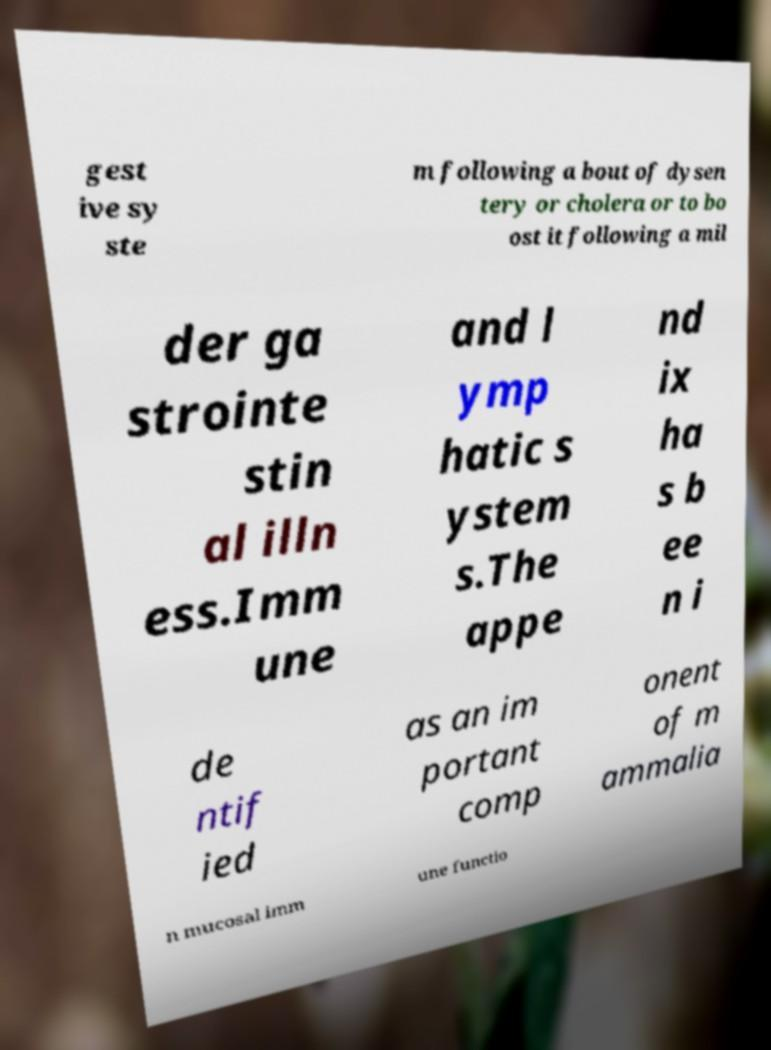Can you read and provide the text displayed in the image?This photo seems to have some interesting text. Can you extract and type it out for me? gest ive sy ste m following a bout of dysen tery or cholera or to bo ost it following a mil der ga strointe stin al illn ess.Imm une and l ymp hatic s ystem s.The appe nd ix ha s b ee n i de ntif ied as an im portant comp onent of m ammalia n mucosal imm une functio 